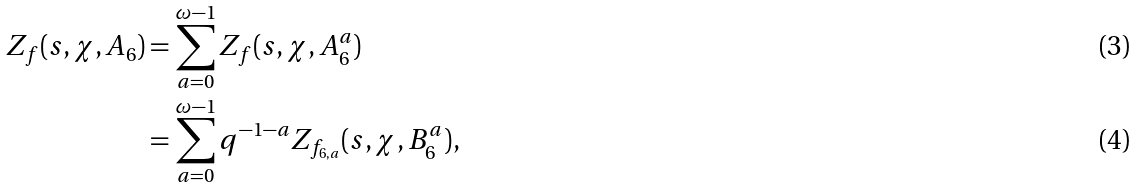<formula> <loc_0><loc_0><loc_500><loc_500>Z _ { f } ( s , \chi , A _ { 6 } ) & = \sum _ { a = 0 } ^ { \omega - 1 } { Z _ { f } ( s , \chi , A _ { 6 } ^ { a } ) } \\ & = \sum _ { a = 0 } ^ { \omega - 1 } q ^ { - 1 - a } Z _ { f _ { 6 , a } } ( s , \chi , B _ { 6 } ^ { a } ) ,</formula> 